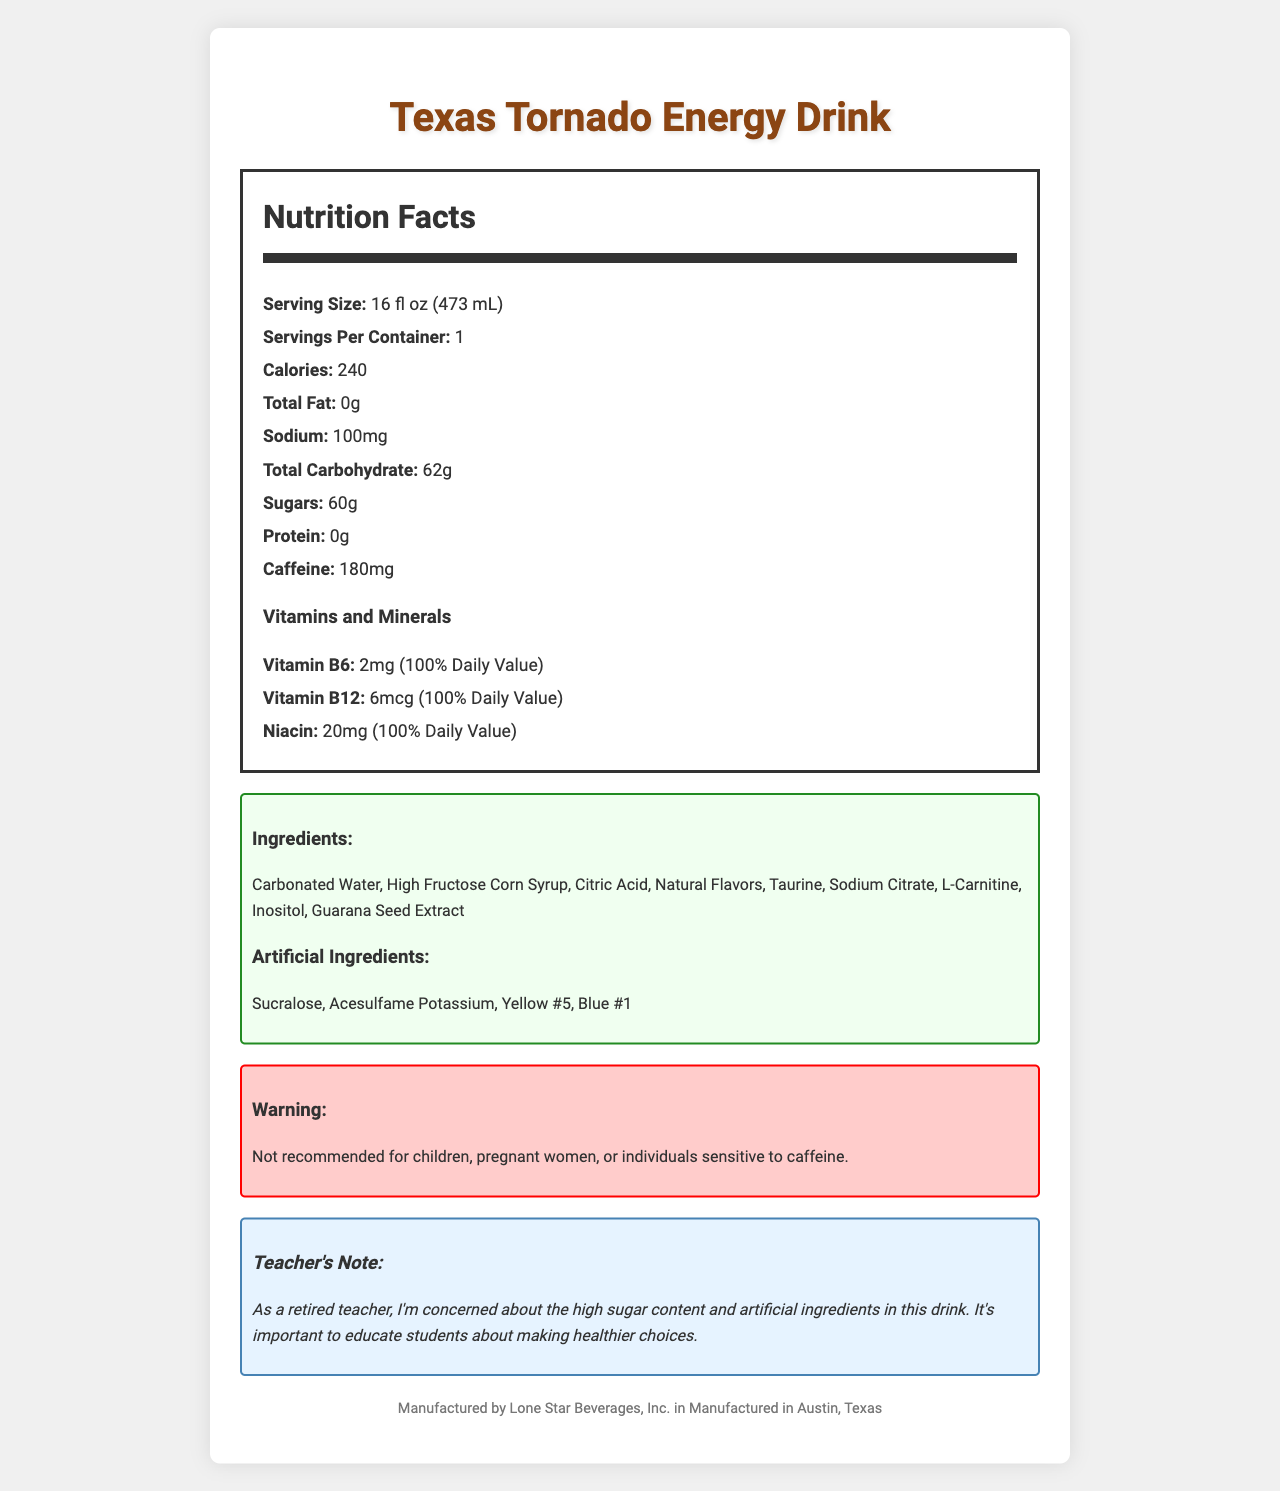What is the serving size of the Texas Tornado Energy Drink? The serving size is explicitly mentioned as "16 fl oz (473 mL)" on the nutrition label.
Answer: 16 fl oz (473 mL) How many grams of sugar does the drink contain? The label states that the drink contains 60 grams of sugar.
Answer: 60g How much caffeine is in one serving? The amount of caffeine per serving is listed as 180mg.
Answer: 180mg What are the artificial ingredients listed in the drink? These ingredients are specifically categorized and listed as artificial ingredients.
Answer: Sucralose, Acesulfame Potassium, Yellow #5, Blue #1 How many calories are in one container of the Texas Tornado Energy Drink? The label states that there are 240 calories in one container, as the serving size and servings per container are the same.
Answer: 240 How much sodium does the energy drink have? According to the nutrition label, the drink contains 100mg of sodium.
Answer: 100mg Which vitamins are present with their Daily Value percentage? The vitamins and their daily values are listed: Vitamin B6 (100%), Vitamin B12 (100%), and Niacin (100%).
Answer: Vitamin B6 (100%), Vitamin B12 (100%), Niacin (100%) How much protein does the energy drink have? The label indicates that the drink contains 0 grams of protein.
Answer: 0g Which of the following is not listed as an artificial ingredient? 
A. Sucralose 
B. Yellow #5 
C. Citric Acid 
D. Acesulfame Potassium Citric Acid is listed under "other ingredients," not under artificial ingredients.
Answer: C. Citric Acid What is the recommended audience warning for this energy drink? The warning section on the label clearly states that it is not recommended for these groups of people.
Answer: Not recommended for children, pregnant women, or individuals sensitive to caffeine. Does the document mention where the Texas Tornado Energy Drink is manufactured? The bottom of the document states that it is manufactured in Austin, Texas by Lone Star Beverages, Inc.
Answer: Yes Summarize the key nutritional facts of the Texas Tornado Energy Drink. The summary covers the primary nutritional information and ingredients as listed on the document, ensuring to highlight key elements that are important for understanding the drink's nutritional value.
Answer: The Texas Tornado Energy Drink has 240 calories per 16 fl oz serving with 60 grams of sugar and 180mg of caffeine. It contains no fats or proteins. It has 100mg of sodium and is fortified with 100% of the daily value for Vitamin B6, Vitamin B12, and Niacin. It also contains artificial ingredients like Sucralose, Acesulfame Potassium, Yellow #5, and Blue #1. How many servings are there per container of Texas Tornado Energy Drink? The label specifies that there is 1 serving per container.
Answer: 1 Can you determine if the energy drink contains gluten based on this document? The document does not provide any information regarding gluten content.
Answer: Cannot be determined What is one concern the retired teacher noted about the energy drink? The teacher’s note section specifically mentions concerns about the high sugar content and artificial ingredients in the drink.
Answer: High sugar content and artificial ingredients 